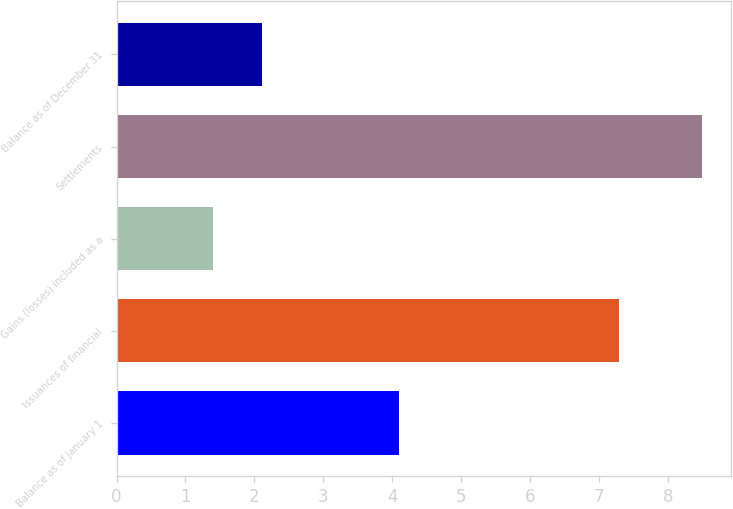<chart> <loc_0><loc_0><loc_500><loc_500><bar_chart><fcel>Balance as of January 1<fcel>Issuances of financial<fcel>Gains (losses) included as a<fcel>Settlements<fcel>Balance as of December 31<nl><fcel>4.1<fcel>7.3<fcel>1.4<fcel>8.5<fcel>2.11<nl></chart> 